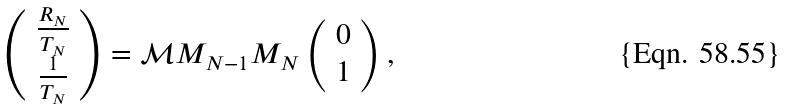<formula> <loc_0><loc_0><loc_500><loc_500>\left ( \begin{array} { c } \frac { R _ { N } } { T _ { N } } \\ \frac { 1 } { T _ { N } } \\ \end{array} \right ) = \mathcal { M } M _ { N - 1 } M _ { N } \left ( \begin{array} { c } 0 \\ 1 \\ \end{array} \right ) ,</formula> 